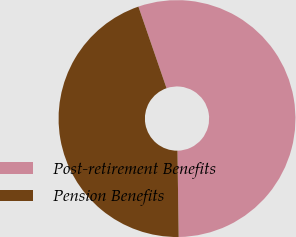Convert chart. <chart><loc_0><loc_0><loc_500><loc_500><pie_chart><fcel>Post-retirement Benefits<fcel>Pension Benefits<nl><fcel>55.06%<fcel>44.94%<nl></chart> 